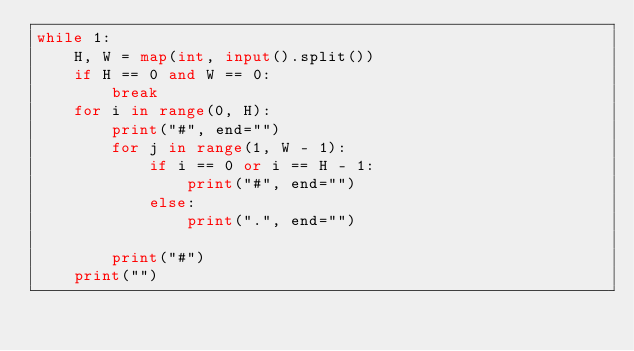<code> <loc_0><loc_0><loc_500><loc_500><_Python_>while 1:
    H, W = map(int, input().split())
    if H == 0 and W == 0:
        break
    for i in range(0, H):
        print("#", end="")
        for j in range(1, W - 1):
            if i == 0 or i == H - 1:
                print("#", end="")
            else:
                print(".", end="")

        print("#")
    print("")</code> 